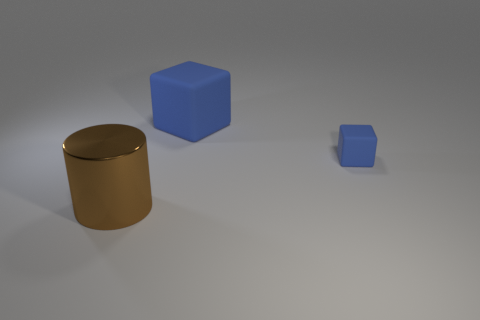The thing that is the same material as the small block is what size?
Make the answer very short. Large. There is another blue thing that is the same size as the shiny thing; what material is it?
Give a very brief answer. Rubber. What number of other objects are the same color as the small rubber block?
Your answer should be very brief. 1. What shape is the thing that is to the left of the large blue object?
Provide a short and direct response. Cylinder. Are there fewer large cylinders than blue rubber things?
Offer a terse response. Yes. Is the material of the large object on the right side of the brown metal object the same as the big brown cylinder?
Offer a terse response. No. Are there any other things that have the same size as the metallic object?
Provide a short and direct response. Yes. There is a tiny thing; are there any blocks left of it?
Your answer should be very brief. Yes. What is the color of the thing to the right of the rubber thing that is behind the blue cube that is in front of the large blue rubber block?
Offer a very short reply. Blue. There is a blue rubber thing that is the same size as the brown metal cylinder; what shape is it?
Your answer should be very brief. Cube. 